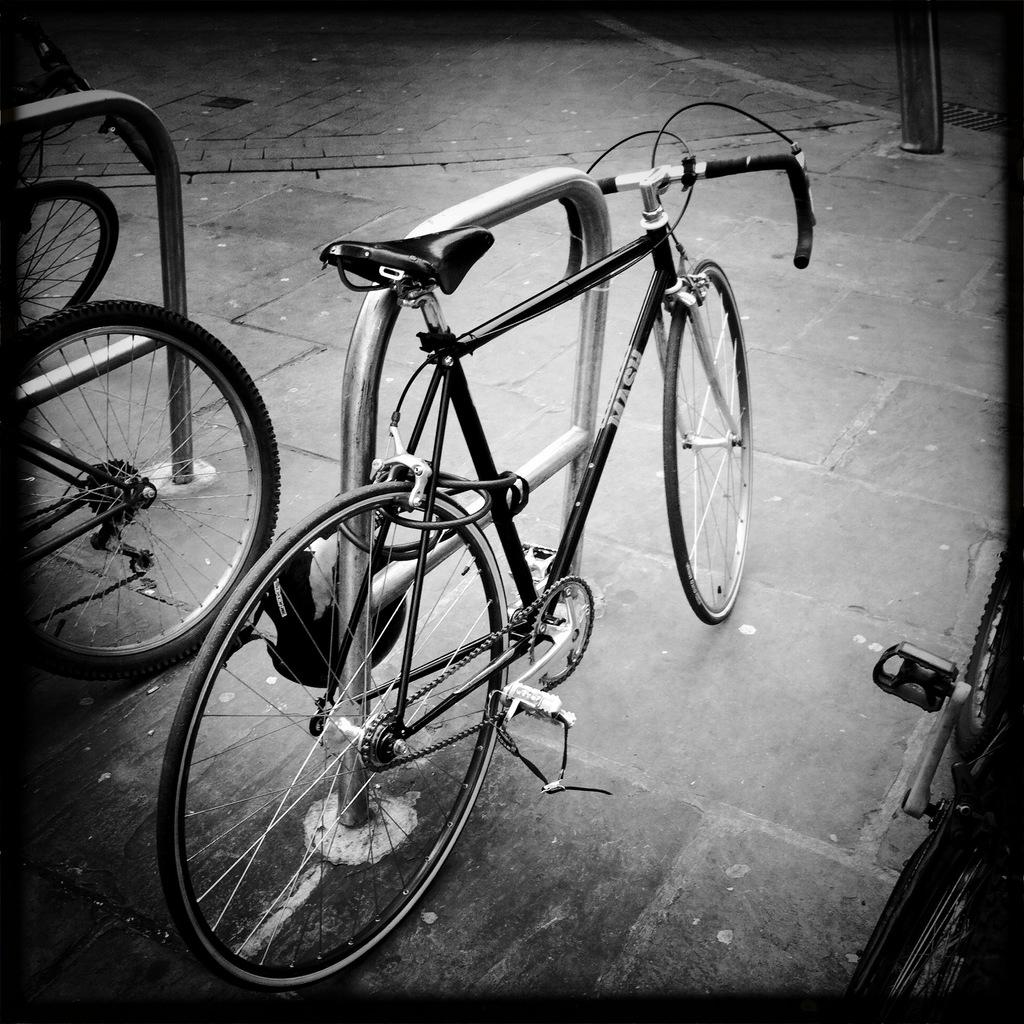What is attached to the metal stand in the image? There is a bicycle locked to a metal stand in the image. Where is the metal stand located? The metal stand is located on the side of the road. Are there any other bicycles in the vicinity? Yes, there are other bicycles nearby. What type of needle can be seen in the image? There is no needle present in the image. Is the bicycle located on an island in the image? The image does not depict an island, so the bicycle is not located on an island. 